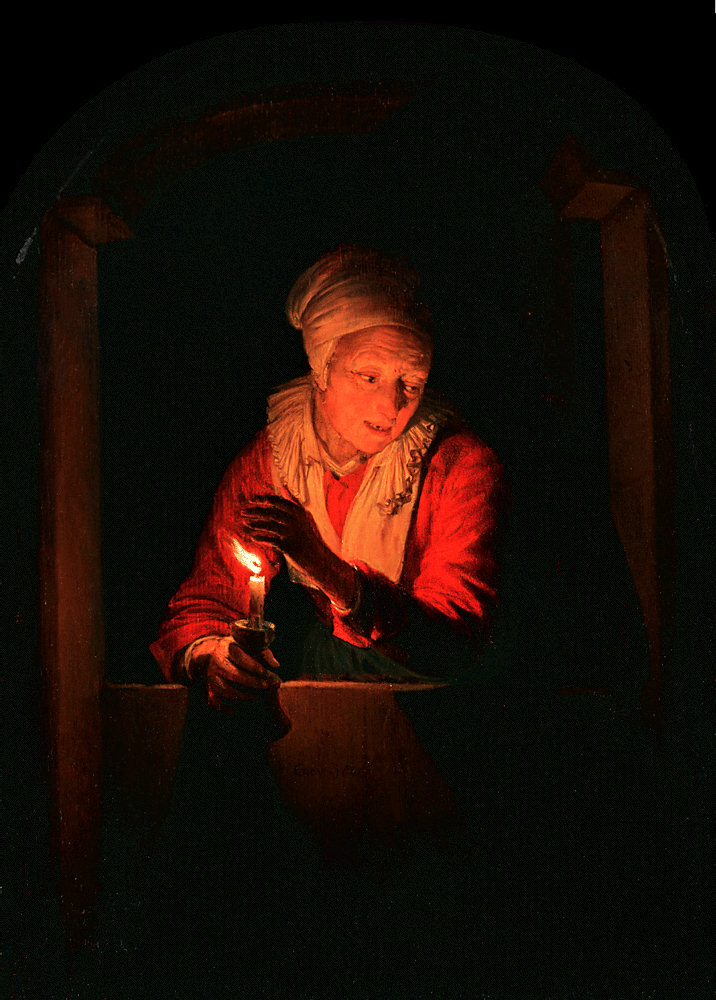What do you think the woman is thinking about while holding the candle? The woman in the painting, gently holding the candle, seems to be lost in deep thoughts. Perhaps she is reminiscing about days gone by, reflecting on cherished memories of her youth, or thinking about loved ones she holds dear. The soft glow of the candlelight illuminating her face adds a touch of nostalgia and tranquility to her contemplative state. 